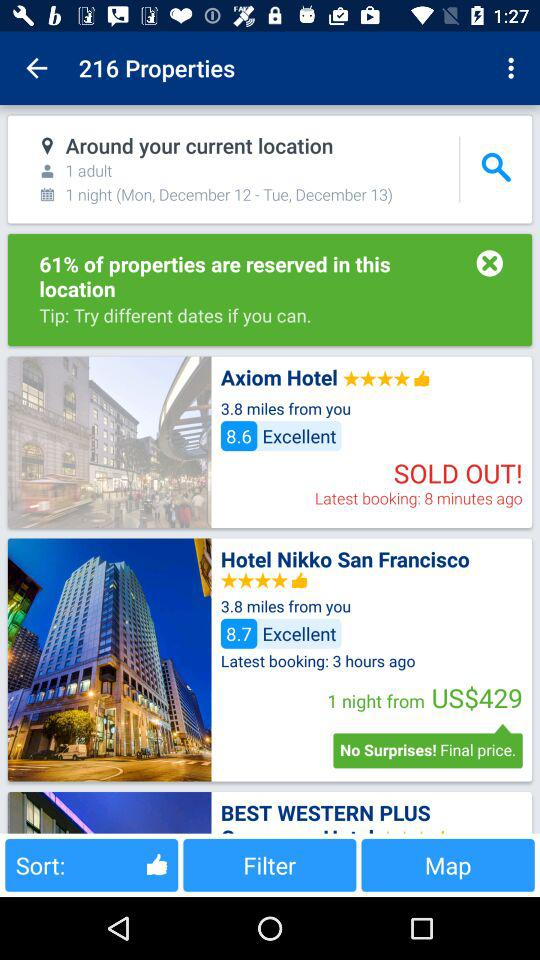What is the number of properties? The number of properties is 216. 